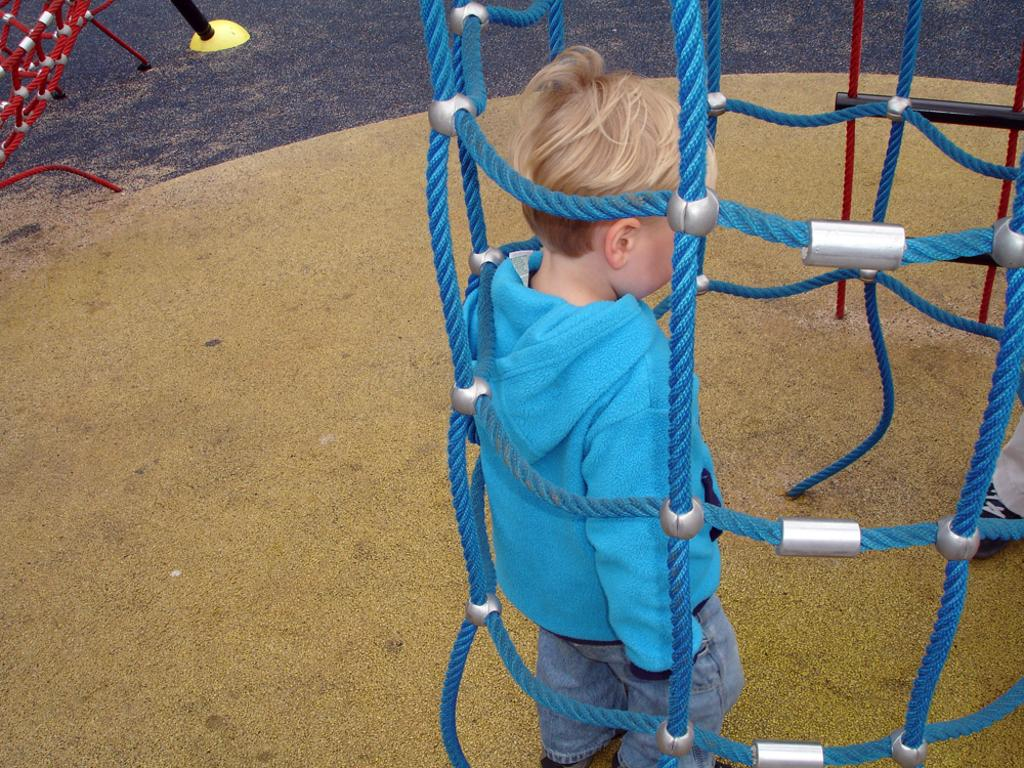Who is present in the image? There is a boy in the image. What is the boy's position in relation to the ropes? The boy is standing behind the ropes. Can you describe the object on the land in the image? Unfortunately, the facts provided do not give any information about the object on the land. What type of jeans is the boy wearing in the image? The facts provided do not mention the boy's clothing, so we cannot determine if he is wearing jeans or any other type of clothing. 